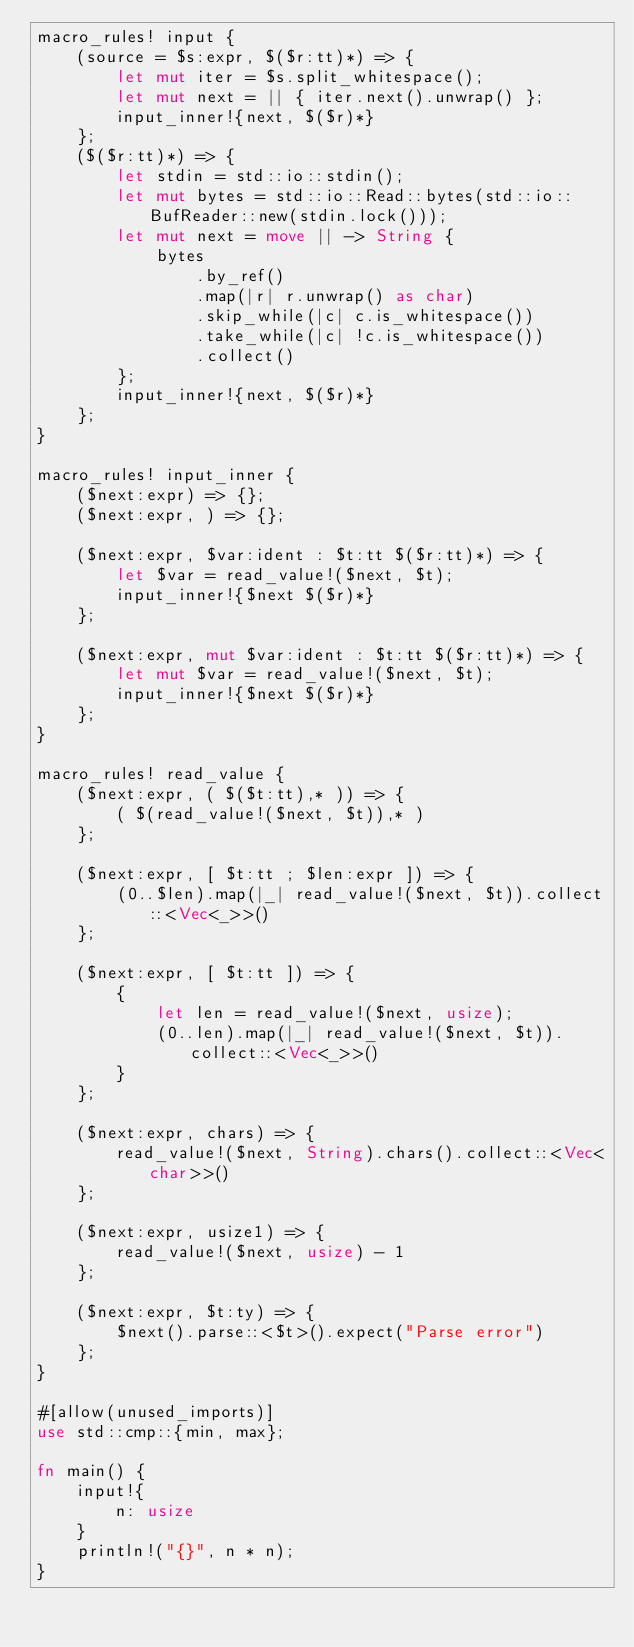<code> <loc_0><loc_0><loc_500><loc_500><_Rust_>macro_rules! input {
    (source = $s:expr, $($r:tt)*) => {
        let mut iter = $s.split_whitespace();
        let mut next = || { iter.next().unwrap() };
        input_inner!{next, $($r)*}
    };
    ($($r:tt)*) => {
        let stdin = std::io::stdin();
        let mut bytes = std::io::Read::bytes(std::io::BufReader::new(stdin.lock()));
        let mut next = move || -> String {
            bytes
                .by_ref()
                .map(|r| r.unwrap() as char)
                .skip_while(|c| c.is_whitespace())
                .take_while(|c| !c.is_whitespace())
                .collect()
        };
        input_inner!{next, $($r)*}
    };
}

macro_rules! input_inner {
    ($next:expr) => {};
    ($next:expr, ) => {};

    ($next:expr, $var:ident : $t:tt $($r:tt)*) => {
        let $var = read_value!($next, $t);
        input_inner!{$next $($r)*}
    };

    ($next:expr, mut $var:ident : $t:tt $($r:tt)*) => {
        let mut $var = read_value!($next, $t);
        input_inner!{$next $($r)*}
    };
}

macro_rules! read_value {
    ($next:expr, ( $($t:tt),* )) => {
        ( $(read_value!($next, $t)),* )
    };

    ($next:expr, [ $t:tt ; $len:expr ]) => {
        (0..$len).map(|_| read_value!($next, $t)).collect::<Vec<_>>()
    };

    ($next:expr, [ $t:tt ]) => {
        {
            let len = read_value!($next, usize);
            (0..len).map(|_| read_value!($next, $t)).collect::<Vec<_>>()
        }
    };

    ($next:expr, chars) => {
        read_value!($next, String).chars().collect::<Vec<char>>()
    };

    ($next:expr, usize1) => {
        read_value!($next, usize) - 1
    };

    ($next:expr, $t:ty) => {
        $next().parse::<$t>().expect("Parse error")
    };
}

#[allow(unused_imports)]
use std::cmp::{min, max};

fn main() {
    input!{
        n: usize
    }
    println!("{}", n * n);
}
</code> 